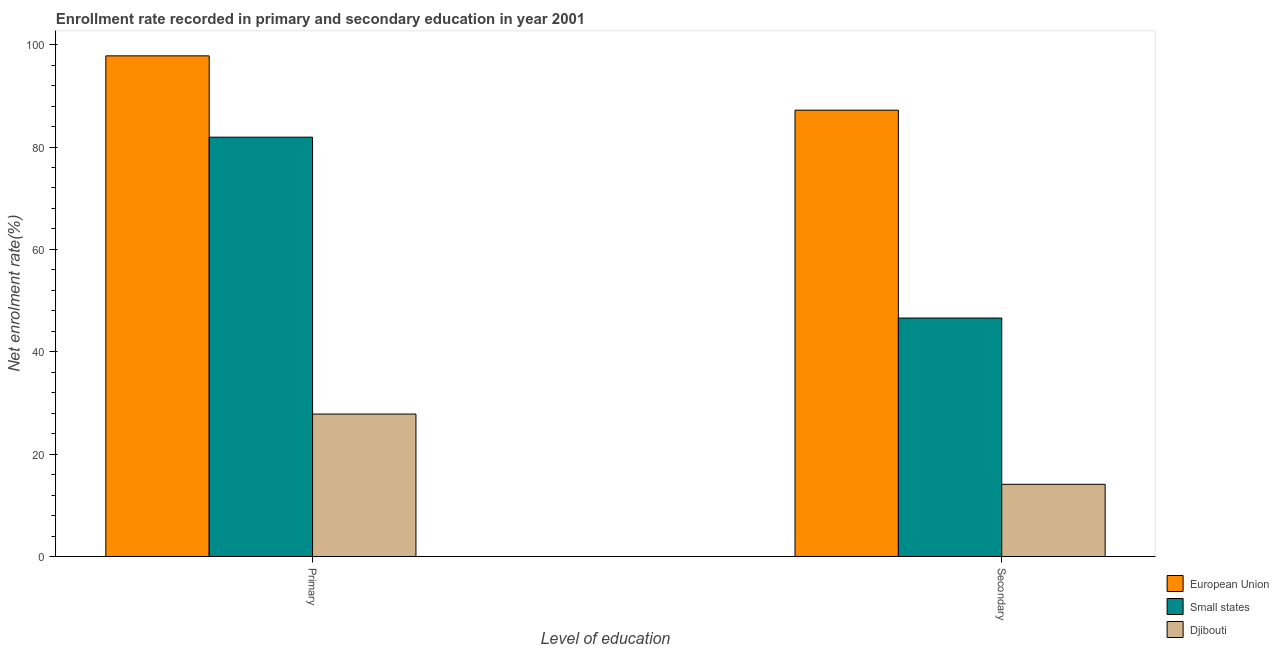How many different coloured bars are there?
Ensure brevity in your answer.  3. Are the number of bars per tick equal to the number of legend labels?
Ensure brevity in your answer.  Yes. How many bars are there on the 2nd tick from the left?
Your response must be concise. 3. What is the label of the 1st group of bars from the left?
Keep it short and to the point. Primary. What is the enrollment rate in secondary education in European Union?
Give a very brief answer. 87.19. Across all countries, what is the maximum enrollment rate in secondary education?
Provide a succinct answer. 87.19. Across all countries, what is the minimum enrollment rate in primary education?
Ensure brevity in your answer.  27.83. In which country was the enrollment rate in primary education minimum?
Give a very brief answer. Djibouti. What is the total enrollment rate in secondary education in the graph?
Keep it short and to the point. 147.89. What is the difference between the enrollment rate in secondary education in Small states and that in European Union?
Your answer should be very brief. -40.61. What is the difference between the enrollment rate in primary education in European Union and the enrollment rate in secondary education in Small states?
Make the answer very short. 51.22. What is the average enrollment rate in secondary education per country?
Keep it short and to the point. 49.3. What is the difference between the enrollment rate in secondary education and enrollment rate in primary education in Djibouti?
Give a very brief answer. -13.72. In how many countries, is the enrollment rate in primary education greater than 68 %?
Your answer should be compact. 2. What is the ratio of the enrollment rate in primary education in Djibouti to that in Small states?
Ensure brevity in your answer.  0.34. In how many countries, is the enrollment rate in primary education greater than the average enrollment rate in primary education taken over all countries?
Your response must be concise. 2. What does the 2nd bar from the right in Primary represents?
Your answer should be compact. Small states. How many bars are there?
Ensure brevity in your answer.  6. Are all the bars in the graph horizontal?
Your answer should be compact. No. What is the difference between two consecutive major ticks on the Y-axis?
Make the answer very short. 20. Are the values on the major ticks of Y-axis written in scientific E-notation?
Give a very brief answer. No. Does the graph contain grids?
Ensure brevity in your answer.  No. Where does the legend appear in the graph?
Provide a succinct answer. Bottom right. How are the legend labels stacked?
Make the answer very short. Vertical. What is the title of the graph?
Ensure brevity in your answer.  Enrollment rate recorded in primary and secondary education in year 2001. What is the label or title of the X-axis?
Keep it short and to the point. Level of education. What is the label or title of the Y-axis?
Keep it short and to the point. Net enrolment rate(%). What is the Net enrolment rate(%) in European Union in Primary?
Give a very brief answer. 97.81. What is the Net enrolment rate(%) of Small states in Primary?
Offer a terse response. 81.92. What is the Net enrolment rate(%) of Djibouti in Primary?
Give a very brief answer. 27.83. What is the Net enrolment rate(%) of European Union in Secondary?
Make the answer very short. 87.19. What is the Net enrolment rate(%) of Small states in Secondary?
Keep it short and to the point. 46.59. What is the Net enrolment rate(%) in Djibouti in Secondary?
Offer a very short reply. 14.11. Across all Level of education, what is the maximum Net enrolment rate(%) of European Union?
Provide a succinct answer. 97.81. Across all Level of education, what is the maximum Net enrolment rate(%) in Small states?
Ensure brevity in your answer.  81.92. Across all Level of education, what is the maximum Net enrolment rate(%) of Djibouti?
Give a very brief answer. 27.83. Across all Level of education, what is the minimum Net enrolment rate(%) in European Union?
Make the answer very short. 87.19. Across all Level of education, what is the minimum Net enrolment rate(%) of Small states?
Your answer should be compact. 46.59. Across all Level of education, what is the minimum Net enrolment rate(%) in Djibouti?
Offer a very short reply. 14.11. What is the total Net enrolment rate(%) of European Union in the graph?
Offer a terse response. 185. What is the total Net enrolment rate(%) in Small states in the graph?
Offer a very short reply. 128.51. What is the total Net enrolment rate(%) of Djibouti in the graph?
Keep it short and to the point. 41.94. What is the difference between the Net enrolment rate(%) of European Union in Primary and that in Secondary?
Your answer should be compact. 10.61. What is the difference between the Net enrolment rate(%) of Small states in Primary and that in Secondary?
Offer a very short reply. 35.33. What is the difference between the Net enrolment rate(%) of Djibouti in Primary and that in Secondary?
Make the answer very short. 13.72. What is the difference between the Net enrolment rate(%) of European Union in Primary and the Net enrolment rate(%) of Small states in Secondary?
Give a very brief answer. 51.22. What is the difference between the Net enrolment rate(%) of European Union in Primary and the Net enrolment rate(%) of Djibouti in Secondary?
Your response must be concise. 83.69. What is the difference between the Net enrolment rate(%) of Small states in Primary and the Net enrolment rate(%) of Djibouti in Secondary?
Keep it short and to the point. 67.81. What is the average Net enrolment rate(%) of European Union per Level of education?
Offer a terse response. 92.5. What is the average Net enrolment rate(%) of Small states per Level of education?
Keep it short and to the point. 64.25. What is the average Net enrolment rate(%) of Djibouti per Level of education?
Your answer should be very brief. 20.97. What is the difference between the Net enrolment rate(%) of European Union and Net enrolment rate(%) of Small states in Primary?
Offer a very short reply. 15.89. What is the difference between the Net enrolment rate(%) of European Union and Net enrolment rate(%) of Djibouti in Primary?
Your response must be concise. 69.98. What is the difference between the Net enrolment rate(%) of Small states and Net enrolment rate(%) of Djibouti in Primary?
Offer a very short reply. 54.09. What is the difference between the Net enrolment rate(%) in European Union and Net enrolment rate(%) in Small states in Secondary?
Give a very brief answer. 40.61. What is the difference between the Net enrolment rate(%) of European Union and Net enrolment rate(%) of Djibouti in Secondary?
Your response must be concise. 73.08. What is the difference between the Net enrolment rate(%) in Small states and Net enrolment rate(%) in Djibouti in Secondary?
Keep it short and to the point. 32.48. What is the ratio of the Net enrolment rate(%) of European Union in Primary to that in Secondary?
Provide a short and direct response. 1.12. What is the ratio of the Net enrolment rate(%) in Small states in Primary to that in Secondary?
Provide a short and direct response. 1.76. What is the ratio of the Net enrolment rate(%) of Djibouti in Primary to that in Secondary?
Ensure brevity in your answer.  1.97. What is the difference between the highest and the second highest Net enrolment rate(%) in European Union?
Keep it short and to the point. 10.61. What is the difference between the highest and the second highest Net enrolment rate(%) of Small states?
Provide a short and direct response. 35.33. What is the difference between the highest and the second highest Net enrolment rate(%) of Djibouti?
Keep it short and to the point. 13.72. What is the difference between the highest and the lowest Net enrolment rate(%) of European Union?
Your answer should be very brief. 10.61. What is the difference between the highest and the lowest Net enrolment rate(%) in Small states?
Your answer should be compact. 35.33. What is the difference between the highest and the lowest Net enrolment rate(%) of Djibouti?
Give a very brief answer. 13.72. 